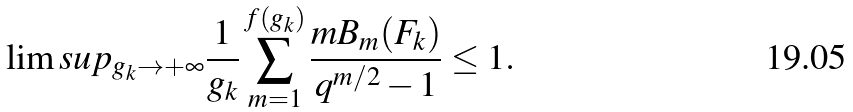Convert formula to latex. <formula><loc_0><loc_0><loc_500><loc_500>\lim s u p _ { g _ { k } \rightarrow + \infty } \frac { 1 } { g _ { k } } \sum _ { m = 1 } ^ { f ( g _ { k } ) } \frac { m B _ { m } ( F _ { k } ) } { q ^ { m / 2 } - 1 } \leq 1 .</formula> 